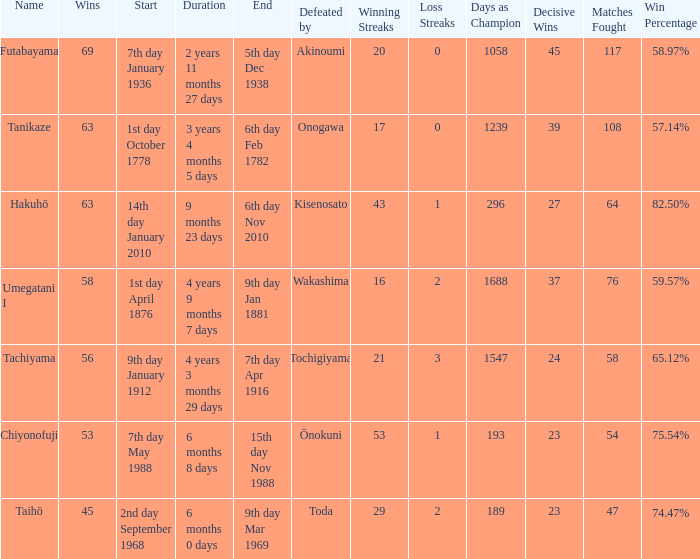What is the Duration for less than 53 consecutive wins? 6 months 0 days. 